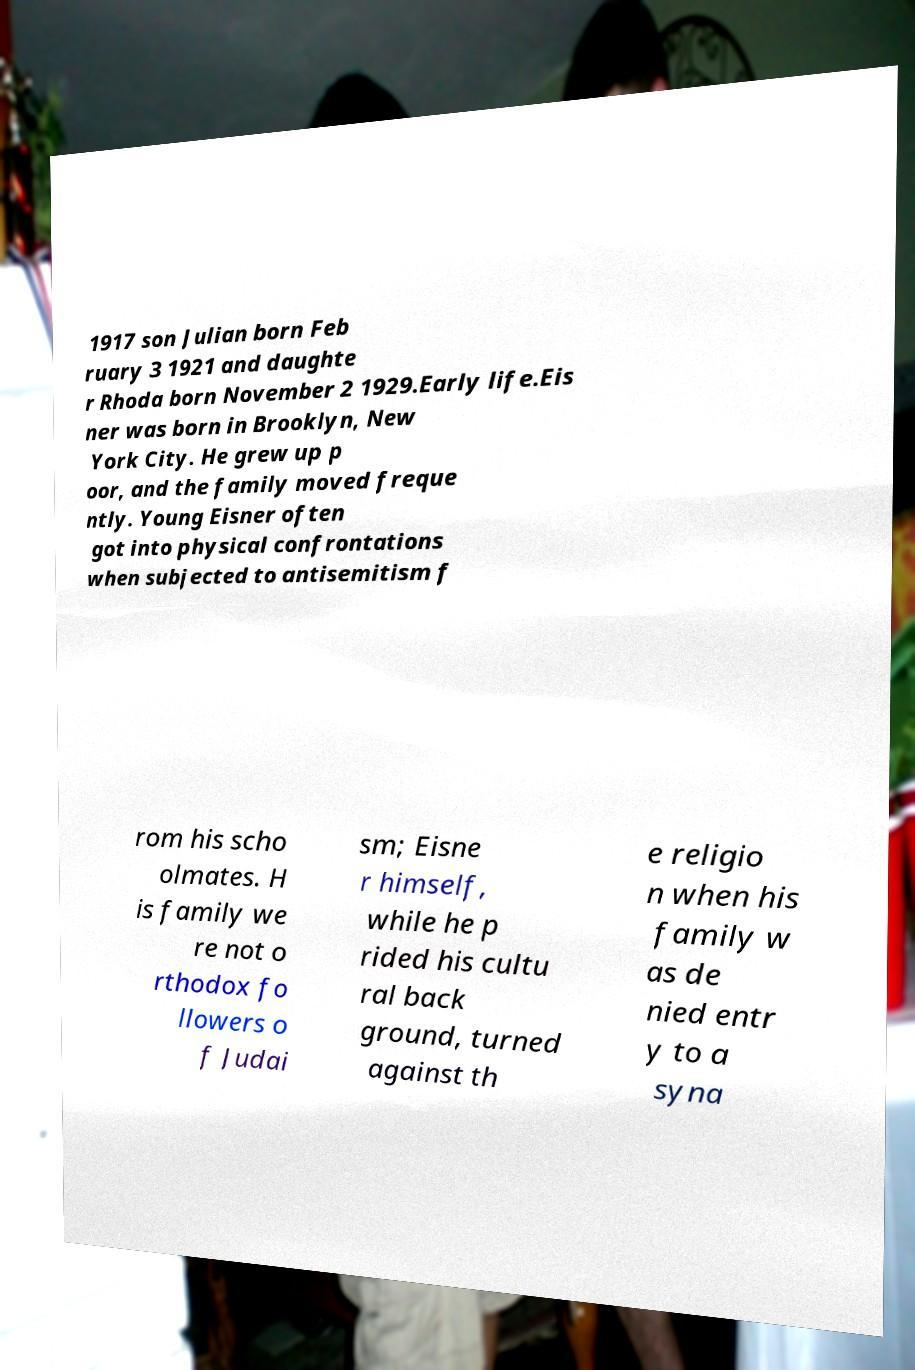Could you extract and type out the text from this image? 1917 son Julian born Feb ruary 3 1921 and daughte r Rhoda born November 2 1929.Early life.Eis ner was born in Brooklyn, New York City. He grew up p oor, and the family moved freque ntly. Young Eisner often got into physical confrontations when subjected to antisemitism f rom his scho olmates. H is family we re not o rthodox fo llowers o f Judai sm; Eisne r himself, while he p rided his cultu ral back ground, turned against th e religio n when his family w as de nied entr y to a syna 